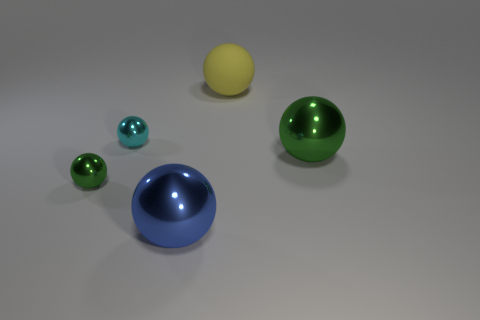Which objects appear to have a reflective surface? All of the objects in the image exhibit reflective properties. You can observe subtle reflections and highlights on each sphere and the hemisphere, indicating they have a shiny or glossy surface. 